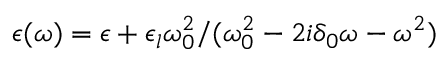<formula> <loc_0><loc_0><loc_500><loc_500>\epsilon ( \omega ) = \epsilon + \epsilon _ { l } \omega _ { 0 } ^ { 2 } / ( \omega _ { 0 } ^ { 2 } - 2 i \delta _ { 0 } \omega - \omega ^ { 2 } )</formula> 